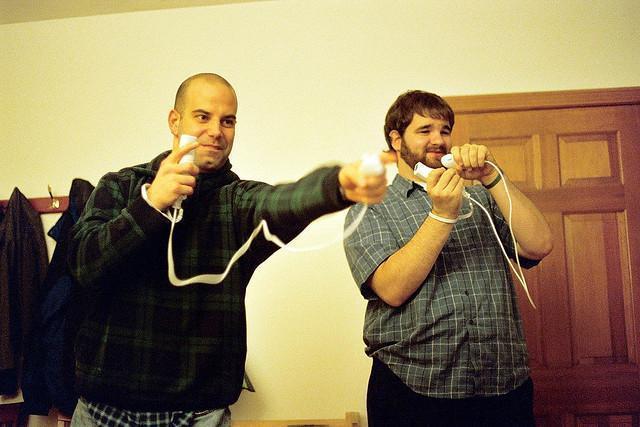How many people?
Give a very brief answer. 2. How many people are in the photo?
Give a very brief answer. 2. 